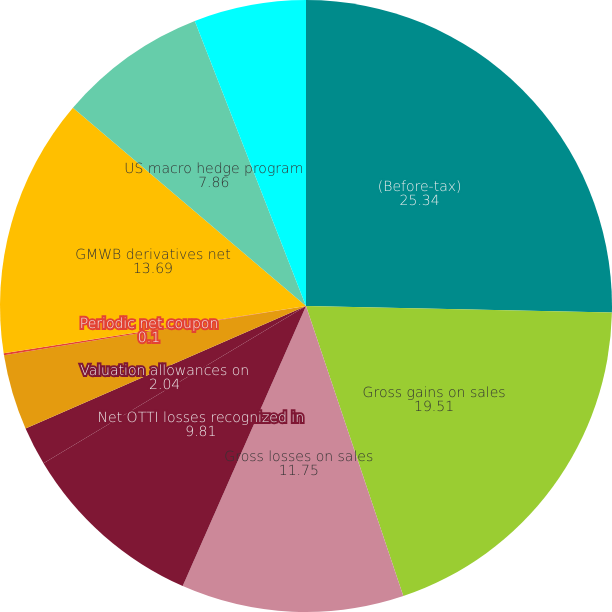Convert chart. <chart><loc_0><loc_0><loc_500><loc_500><pie_chart><fcel>(Before-tax)<fcel>Gross gains on sales<fcel>Gross losses on sales<fcel>Net OTTI losses recognized in<fcel>Valuation allowances on<fcel>Japanese fixed annuity<fcel>Periodic net coupon<fcel>GMWB derivatives net<fcel>US macro hedge program<fcel>Total US program<nl><fcel>25.34%<fcel>19.51%<fcel>11.75%<fcel>9.81%<fcel>2.04%<fcel>3.98%<fcel>0.1%<fcel>13.69%<fcel>7.86%<fcel>5.92%<nl></chart> 